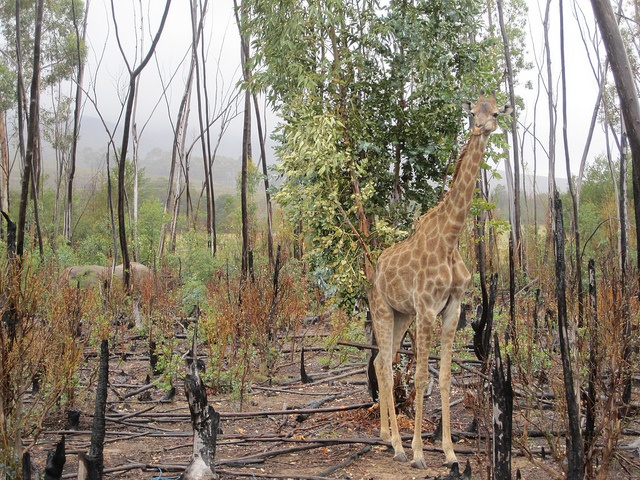Describe the objects in this image and their specific colors. I can see giraffe in darkgray, tan, and gray tones, elephant in darkgray, gray, and tan tones, and elephant in darkgray, tan, and gray tones in this image. 